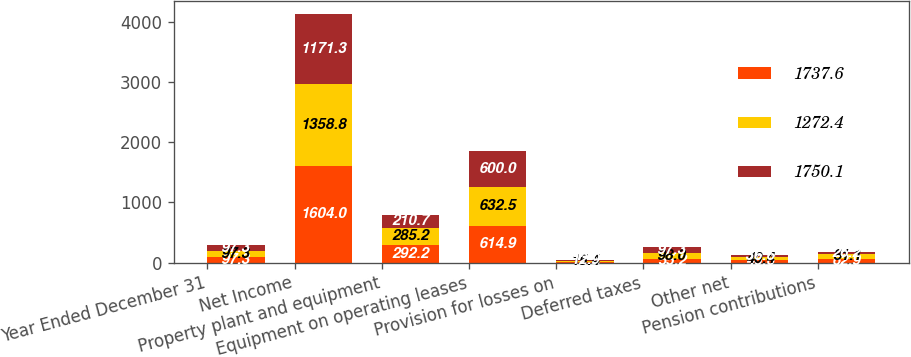Convert chart to OTSL. <chart><loc_0><loc_0><loc_500><loc_500><stacked_bar_chart><ecel><fcel>Year Ended December 31<fcel>Net Income<fcel>Property plant and equipment<fcel>Equipment on operating leases<fcel>Provision for losses on<fcel>Deferred taxes<fcel>Other net<fcel>Pension contributions<nl><fcel>1737.6<fcel>97.3<fcel>1604<fcel>292.2<fcel>614.9<fcel>12.4<fcel>55.2<fcel>46.6<fcel>62.9<nl><fcel>1272.4<fcel>97.3<fcel>1358.8<fcel>285.2<fcel>632.5<fcel>15.4<fcel>98<fcel>40.4<fcel>81.1<nl><fcel>1750.1<fcel>97.3<fcel>1171.3<fcel>210.7<fcel>600<fcel>12.9<fcel>97.3<fcel>36.6<fcel>26.2<nl></chart> 